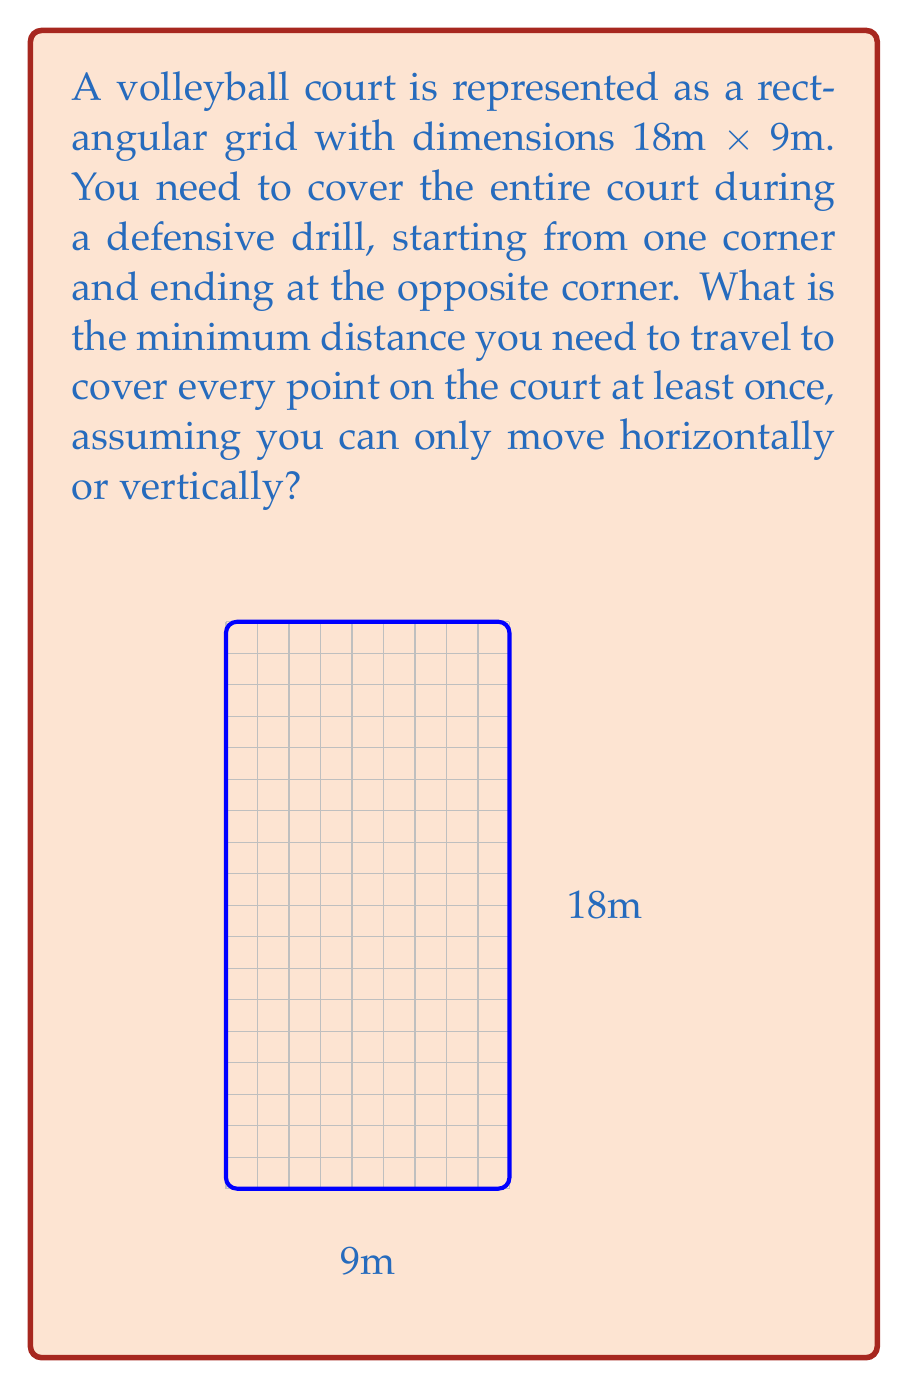Show me your answer to this math problem. To solve this problem, we need to find the shortest path that covers every point on the grid. This is similar to the Traveling Salesman Problem, but with the constraint of only horizontal and vertical movements.

1) First, we need to understand that the minimum path will always consist of moving either right or down, never backtracking.

2) The total number of horizontal steps required is 9 (to cover the width).

3) The total number of vertical steps required is 18 (to cover the length).

4) The optimal path will zigzag across the court, covering each row completely before moving to the next.

5) The total distance traveled will be the sum of all horizontal and vertical movements:

   $$\text{Total Distance} = \text{Horizontal Distance} + \text{Vertical Distance}$$

6) Horizontal Distance: 
   - We need to traverse the width 9 times (once for each meter of length)
   $$9 \times 9\text{m} = 81\text{m}$$

7) Vertical Distance:
   - We need to move down 18 times (once for each meter of length)
   $$18 \times 1\text{m} = 18\text{m}$$

8) Therefore, the total minimum distance is:
   $$\text{Total Distance} = 81\text{m} + 18\text{m} = 99\text{m}$$

This path ensures that every point on the court is covered at least once while minimizing the total distance traveled.
Answer: The minimum distance to cover the entire volleyball court is 99 meters. 